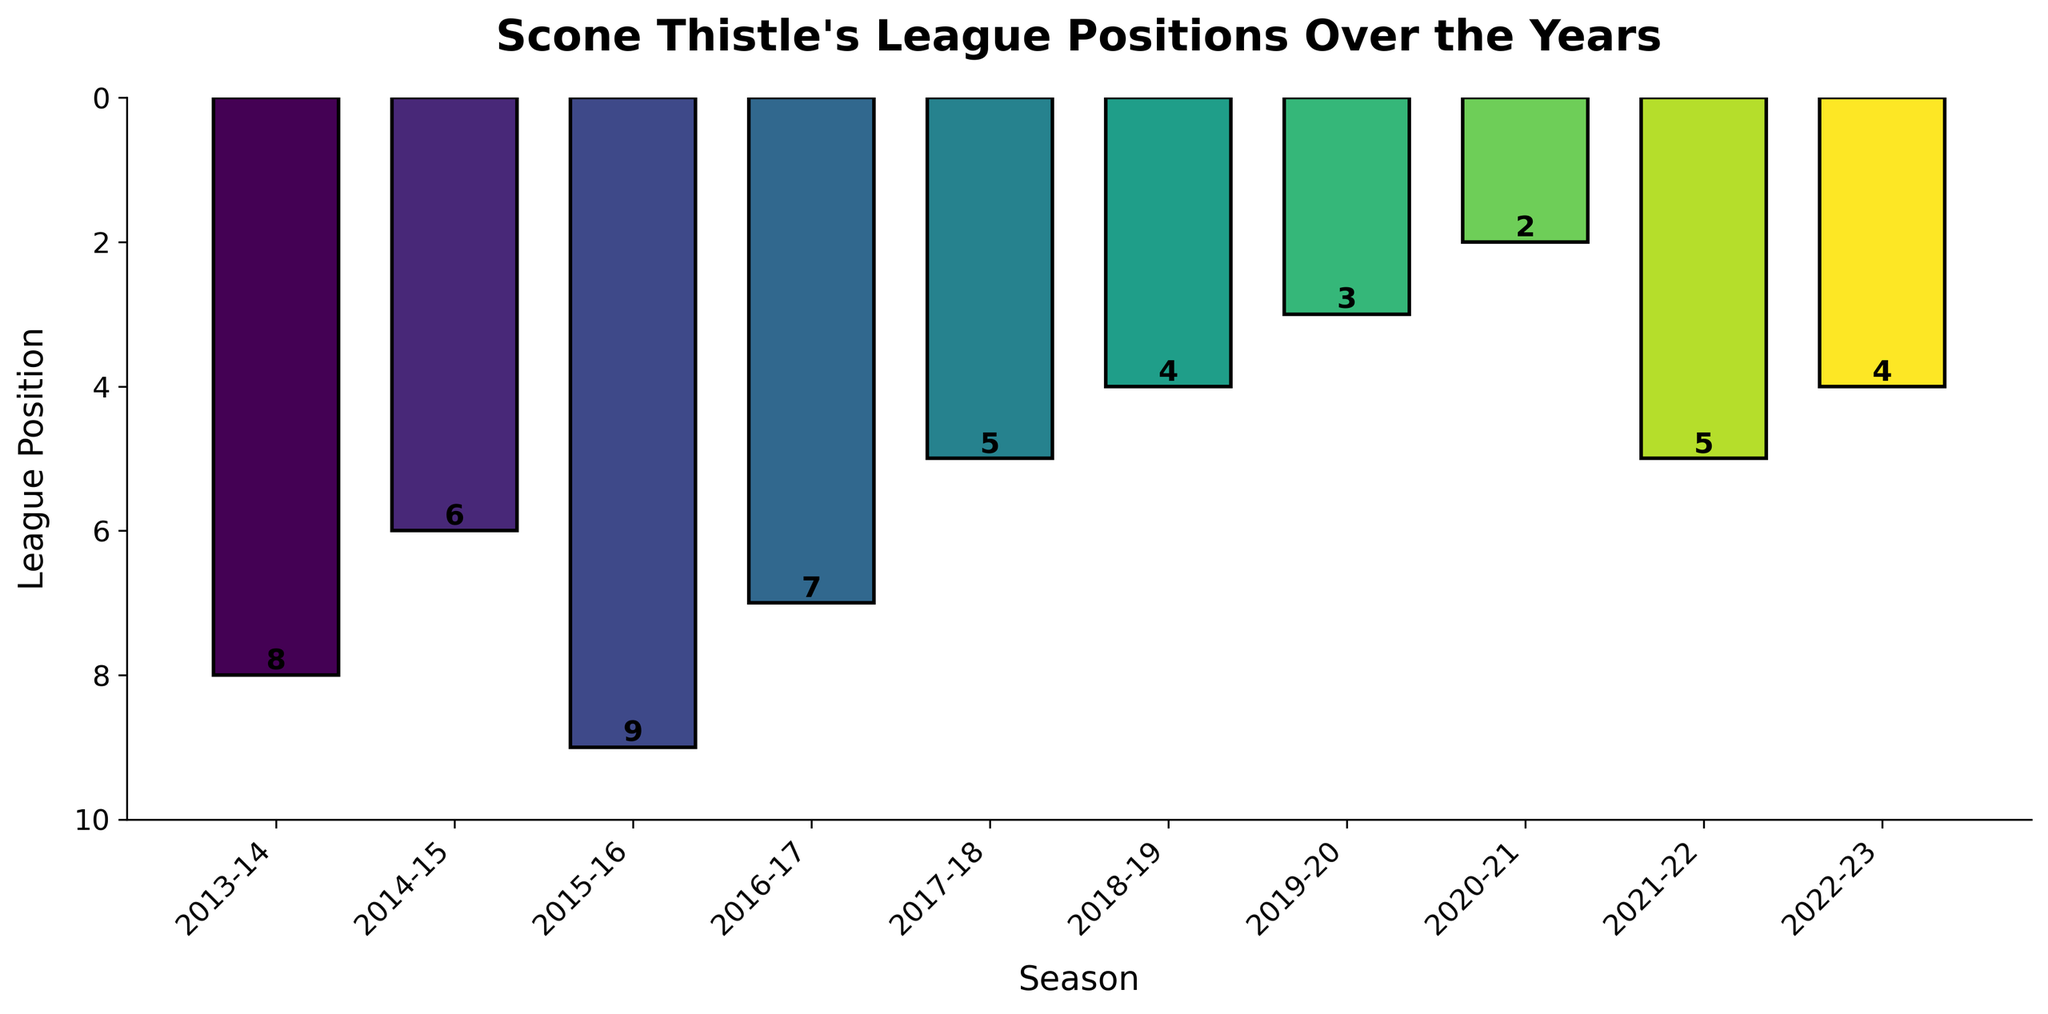What is the highest league position Scone Thistle achieved in the past decade? Refer to the bar with the smallest height in the bar chart, which represents the highest position. Here, it is the bar for the 2020-21 season with a position of 2.
Answer: 2 Which season did Scone Thistle rank 3rd? Look for the bar in the bar chart that has the label "3". The bar labeled "3" corresponds to the 2019-20 season.
Answer: 2019-20 By how many positions did Scone Thistle improve from the 2013-14 season to the 2020-21 season? The position in the 2013-14 season was 8, and in the 2020-21 season, it was 2. The improvement is 8 - 2 = 6 positions.
Answer: 6 What is the average league position over the decade? Sum the league positions from all seasons and divide by the number of seasons: (8 + 6 + 9 + 7 + 5 + 4 + 3 + 2 + 5 + 4) / 10. This calculates to 53 / 10 = 5.3.
Answer: 5.3 In which seasons did Scone Thistle achieve better than a 6th-place finish? Identify bars with a position number less than 6. These bars represent the seasons 2017-18, 2018-19, 2019-20, 2020-21, 2021-22, and 2022-23.
Answer: 2017-18, 2018-19, 2019-20, 2020-21, 2021-22, 2022-23 Which two seasons have bars of the exact same height? Look for bars with identical heights. The seasons 2018-19 and 2022-23 each have a league position of 4.
Answer: 2018-19 and 2022-23 How many consecutive seasons did Scone Thistle improve their positions continuously? Observe the trend of the bar chart to see how many consecutive seasons show a decreasing order of league position. The seasons from 2014-15 to 2020-21 show continuous improvement. This is 6 consecutive seasons.
Answer: 6 What season had the largest decline in position compared to the previous season? Compare the difference in league positions season by season. The largest decline occurs from the 2020-21 season (position 2) to the 2021-22 season (position 5), which is a decline of 3 positions.
Answer: 2021-22 From which season to which season did Scone Thistle show the most improvement? Calculate the improvements by subtracting the positions between each consecutive season, and find the maximum improvement. The largest improvement is from 2013-14 (position 8) to 2020-21 (position 2), showing an improvement of 8 - 2 = 6 positions over 7 seasons.
Answer: From 2013-14 to 2020-21 